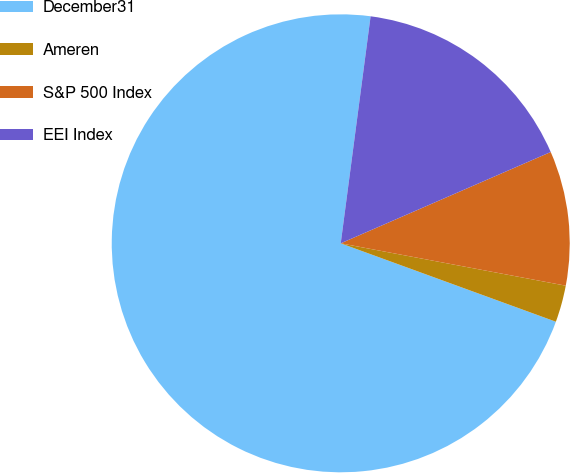Convert chart. <chart><loc_0><loc_0><loc_500><loc_500><pie_chart><fcel>December31<fcel>Ameren<fcel>S&P 500 Index<fcel>EEI Index<nl><fcel>71.52%<fcel>2.6%<fcel>9.49%<fcel>16.39%<nl></chart> 